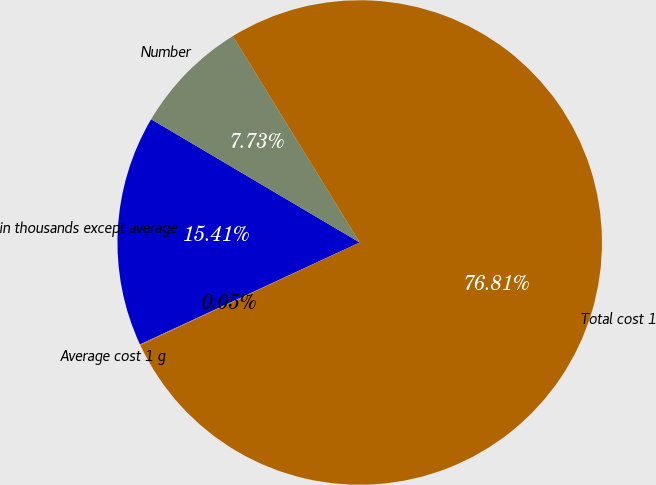Convert chart to OTSL. <chart><loc_0><loc_0><loc_500><loc_500><pie_chart><fcel>in thousands except average<fcel>Number<fcel>Total cost 1<fcel>Average cost 1 g<nl><fcel>15.41%<fcel>7.73%<fcel>76.81%<fcel>0.05%<nl></chart> 